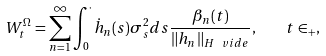<formula> <loc_0><loc_0><loc_500><loc_500>W ^ { \Omega } _ { t } = \sum _ { n = 1 } ^ { \infty } \int _ { 0 } ^ { \cdot } \dot { h } _ { n } ( s ) \sigma ^ { 2 } _ { s } d s \frac { \beta _ { n } ( t ) } { \| h _ { n } \| _ { H ^ { \ } v i d e } } , \quad t \in \real _ { + } ,</formula> 